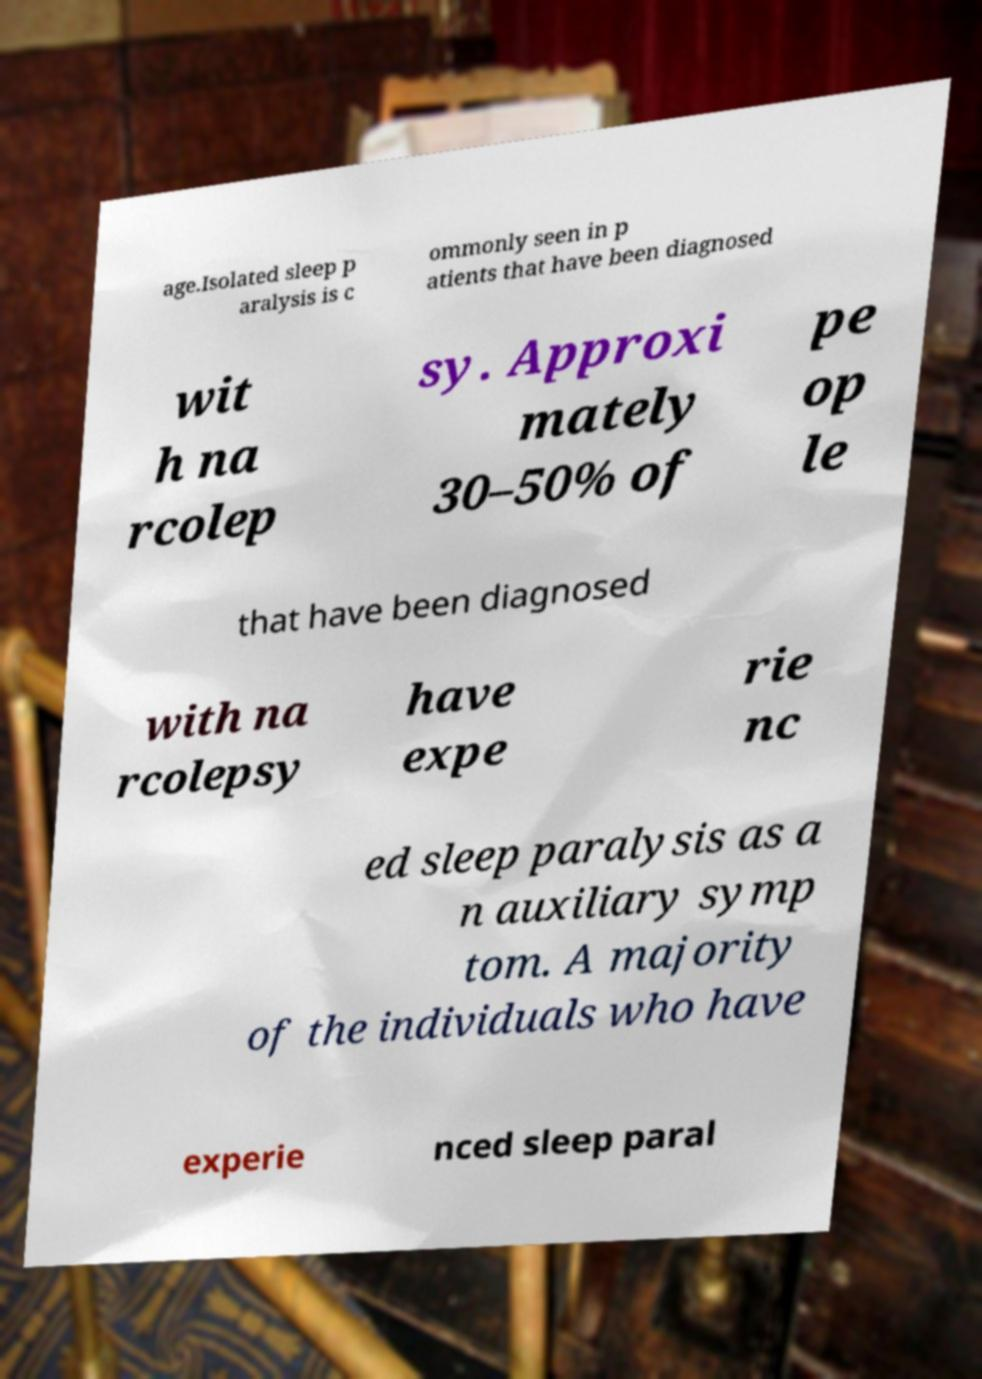Can you read and provide the text displayed in the image?This photo seems to have some interesting text. Can you extract and type it out for me? age.Isolated sleep p aralysis is c ommonly seen in p atients that have been diagnosed wit h na rcolep sy. Approxi mately 30–50% of pe op le that have been diagnosed with na rcolepsy have expe rie nc ed sleep paralysis as a n auxiliary symp tom. A majority of the individuals who have experie nced sleep paral 